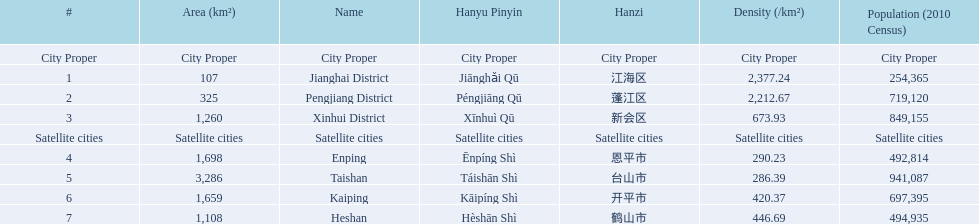Is enping more/less dense than kaiping? Less. 